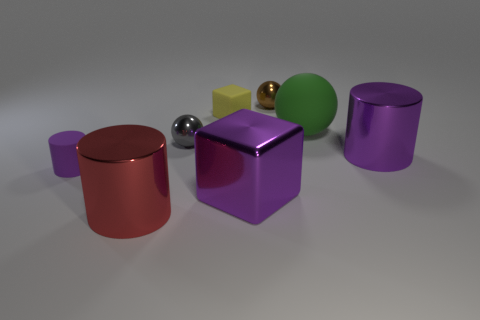Add 1 cyan rubber cylinders. How many objects exist? 9 Subtract all blocks. How many objects are left? 6 Add 7 big metal cylinders. How many big metal cylinders are left? 9 Add 1 yellow objects. How many yellow objects exist? 2 Subtract 0 brown blocks. How many objects are left? 8 Subtract all big cylinders. Subtract all small cylinders. How many objects are left? 5 